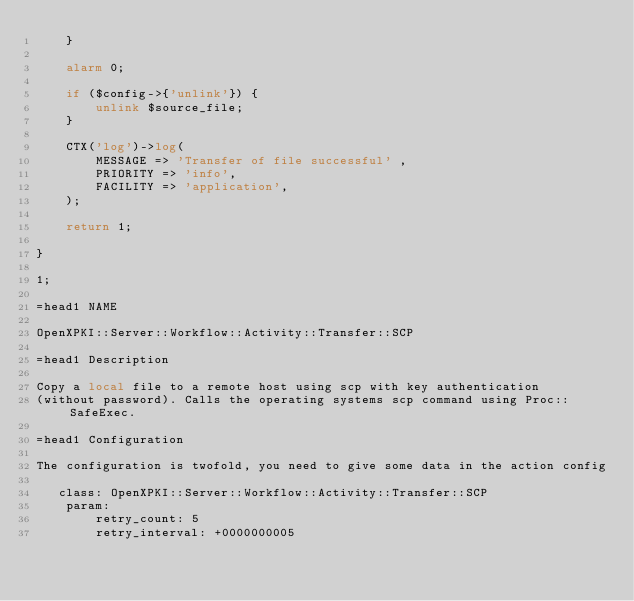<code> <loc_0><loc_0><loc_500><loc_500><_Perl_>	}
	
	alarm 0;
	
	if ($config->{'unlink'}) {
		unlink $source_file;
	} 
	    
    CTX('log')->log(
		MESSAGE => 'Transfer of file successful' ,
		PRIORITY => 'info',
		FACILITY => 'application',
	);
    
    return 1;
    
}

1;

=head1 NAME

OpenXPKI::Server::Workflow::Activity::Transfer::SCP

=head1 Description

Copy a local file to a remote host using scp with key authentication
(without password). Calls the operating systems scp command using Proc::SafeExec.

=head1 Configuration

The configuration is twofold, you need to give some data in the action config

   class: OpenXPKI::Server::Workflow::Activity::Transfer::SCP
    param:
        retry_count: 5
        retry_interval: +0000000005</code> 